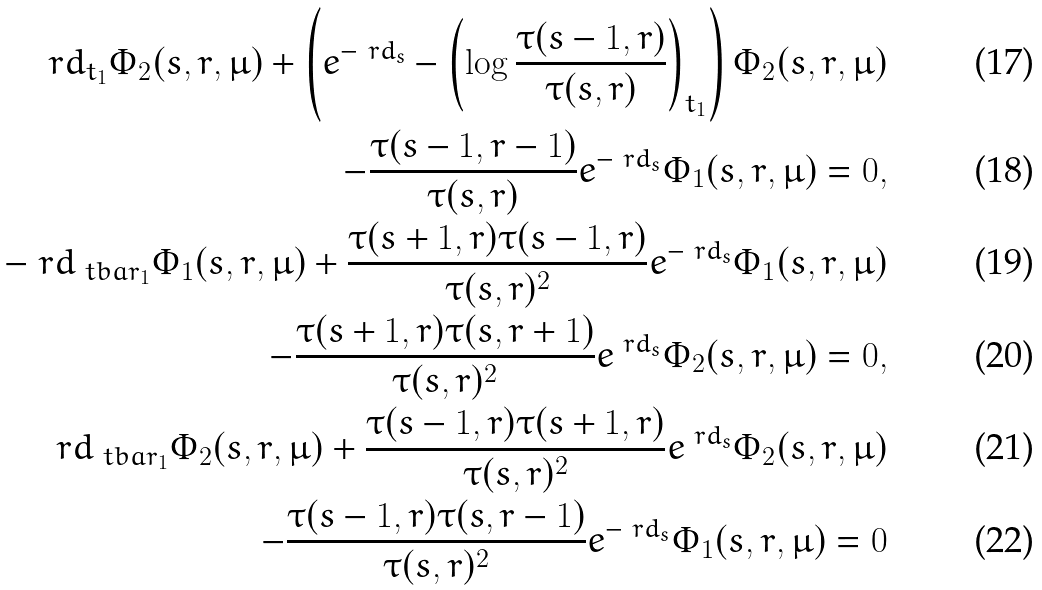Convert formula to latex. <formula><loc_0><loc_0><loc_500><loc_500>\ r d _ { t _ { 1 } } \Phi _ { 2 } ( s , r , \mu ) + \left ( e ^ { - \ r d _ { s } } - \left ( \log \frac { \tau ( s - 1 , r ) } { \tau ( s , r ) } \right ) _ { t _ { 1 } } \right ) \Phi _ { 2 } ( s , r , \mu ) \\ - \frac { \tau ( s - 1 , r - 1 ) } { \tau ( s , r ) } e ^ { - \ r d _ { s } } \Phi _ { 1 } ( s , r , \mu ) = 0 , \\ - \ r d _ { \ t b a r _ { 1 } } \Phi _ { 1 } ( s , r , \mu ) + \frac { \tau ( s + 1 , r ) \tau ( s - 1 , r ) } { \tau ( s , r ) ^ { 2 } } e ^ { - \ r d _ { s } } \Phi _ { 1 } ( s , r , \mu ) \\ - \frac { \tau ( s + 1 , r ) \tau ( s , r + 1 ) } { \tau ( s , r ) ^ { 2 } } e ^ { \ r d _ { s } } \Phi _ { 2 } ( s , r , \mu ) = 0 , \\ \ r d _ { \ t b a r _ { 1 } } \Phi _ { 2 } ( s , r , \mu ) + \frac { \tau ( s - 1 , r ) \tau ( s + 1 , r ) } { \tau ( s , r ) ^ { 2 } } e ^ { \ r d _ { s } } \Phi _ { 2 } ( s , r , \mu ) \\ - \frac { \tau ( s - 1 , r ) \tau ( s , r - 1 ) } { \tau ( s , r ) ^ { 2 } } e ^ { - \ r d _ { s } } \Phi _ { 1 } ( s , r , \mu ) = 0</formula> 